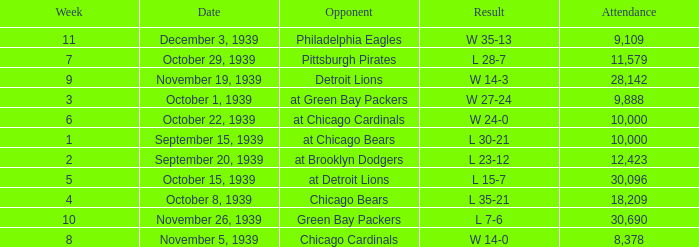Which Attendance has an Opponent of green bay packers, and a Week larger than 10? None. 